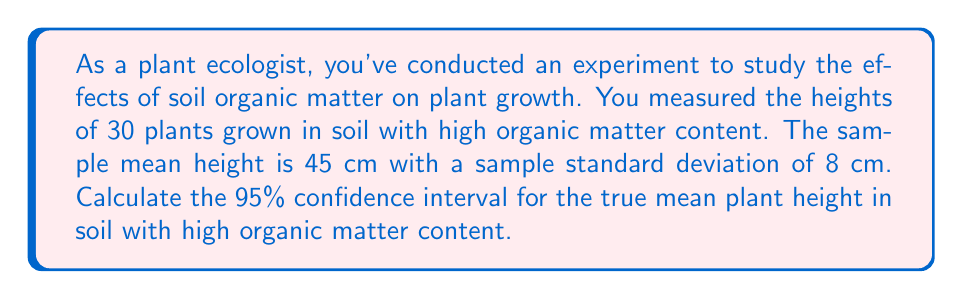Give your solution to this math problem. To calculate the confidence interval, we'll use the formula:

$$ \text{CI} = \bar{x} \pm t_{\alpha/2, n-1} \cdot \frac{s}{\sqrt{n}} $$

Where:
$\bar{x}$ = sample mean = 45 cm
$s$ = sample standard deviation = 8 cm
$n$ = sample size = 30
$t_{\alpha/2, n-1}$ = t-value for 95% confidence level with 29 degrees of freedom

Steps:
1. Find the t-value:
   For 95% confidence level and 29 degrees of freedom, $t_{\alpha/2, n-1} = t_{0.025, 29} = 2.045$ (from t-distribution table)

2. Calculate the standard error of the mean:
   $SE = \frac{s}{\sqrt{n}} = \frac{8}{\sqrt{30}} = 1.46$ cm

3. Calculate the margin of error:
   $ME = t_{\alpha/2, n-1} \cdot SE = 2.045 \cdot 1.46 = 2.99$ cm

4. Calculate the confidence interval:
   $\text{CI} = 45 \pm 2.99$
   Lower bound: $45 - 2.99 = 42.01$ cm
   Upper bound: $45 + 2.99 = 47.99$ cm
Answer: (42.01 cm, 47.99 cm) 